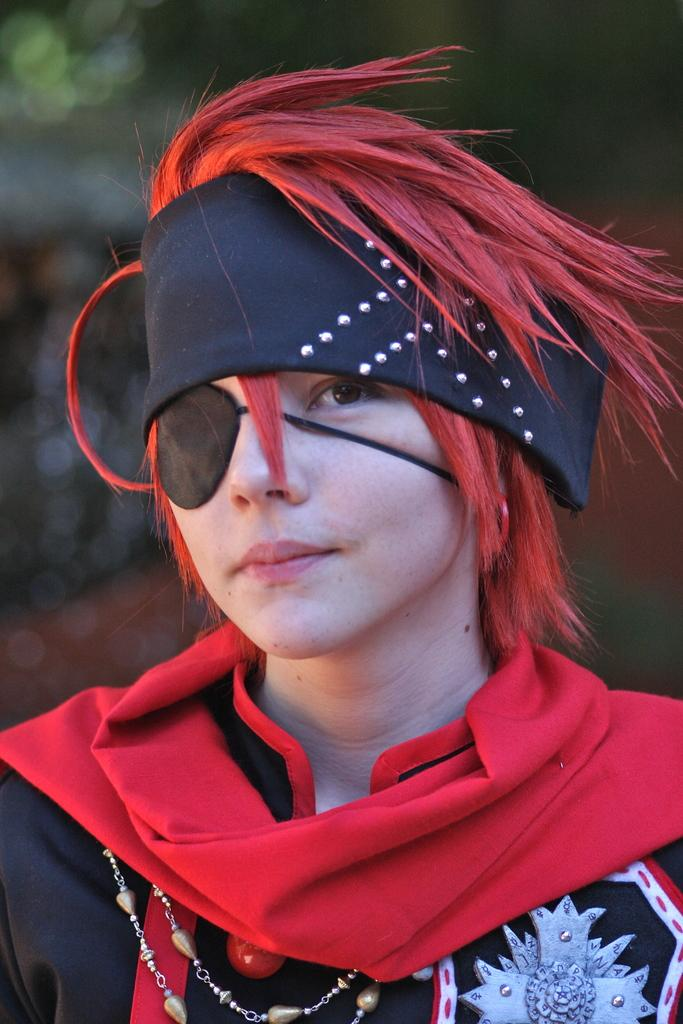What can be seen in the image? There is a person in the image. What is distinctive about the person's appearance? The person is wearing a costume and has red hair. What accessory is the person wearing on their head? The person is wearing a black kerchief tied on their head. What type of teeth does the expert have in the image? There is no expert or mention of teeth in the image; it features a person wearing a costume with red hair and a black kerchief tied on their head. 